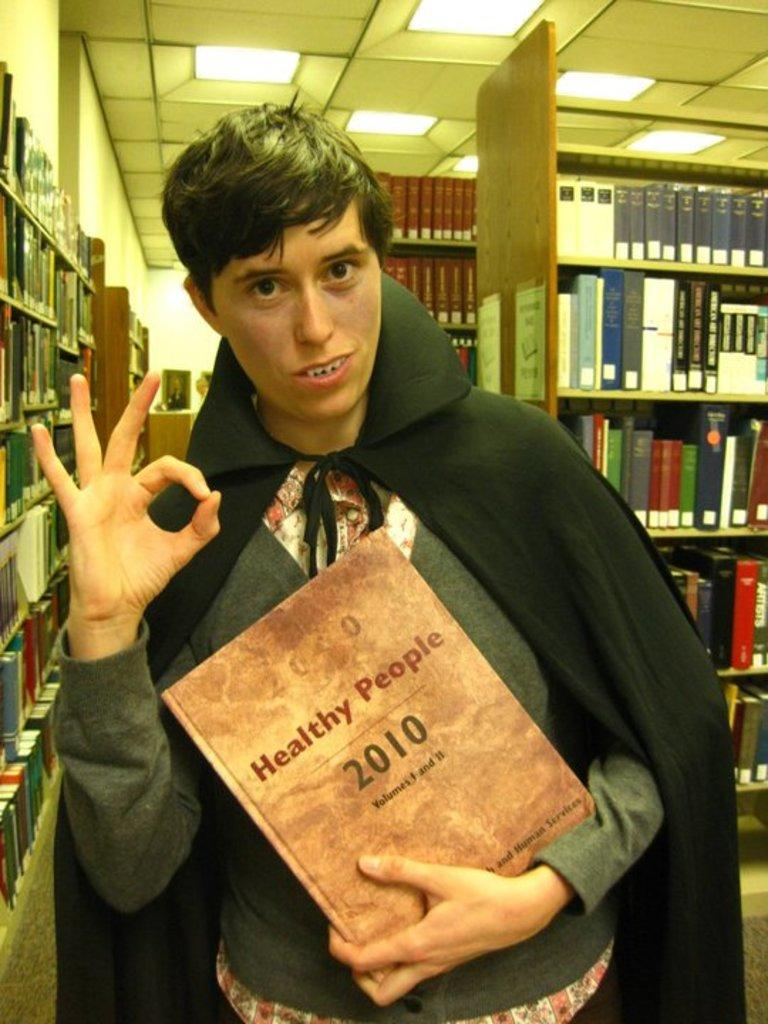<image>
Write a terse but informative summary of the picture. a vampire kid with a book about healthy people 